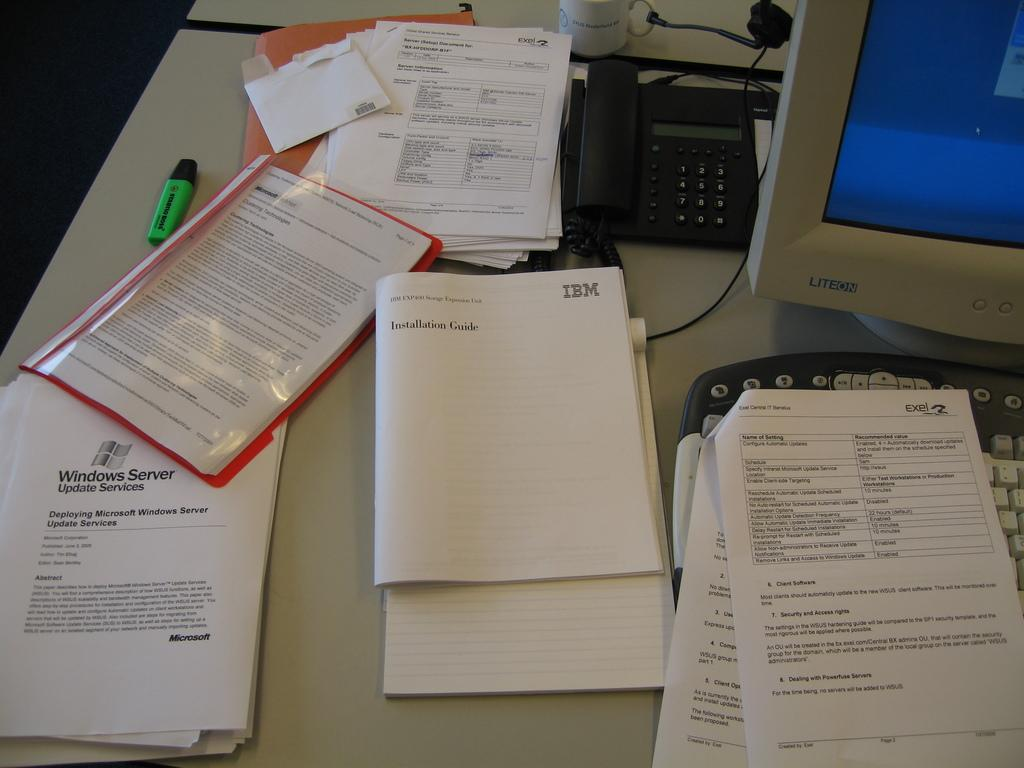<image>
Share a concise interpretation of the image provided. A Liteon monitor with various paperwork from IBM and exel. 